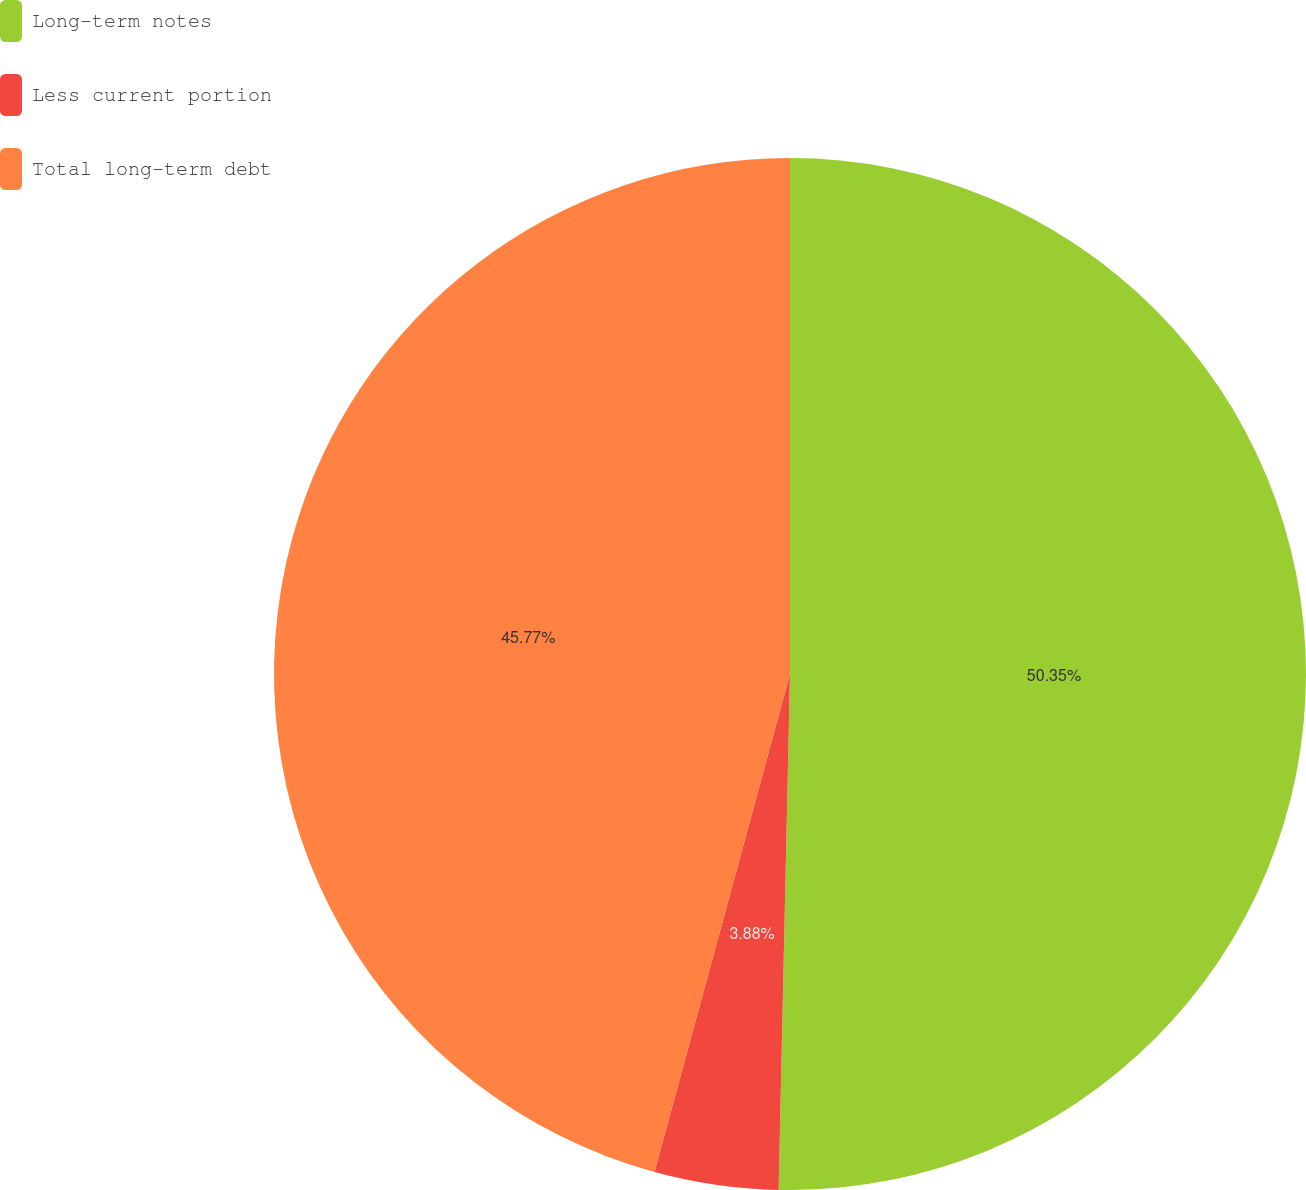Convert chart. <chart><loc_0><loc_0><loc_500><loc_500><pie_chart><fcel>Long-term notes<fcel>Less current portion<fcel>Total long-term debt<nl><fcel>50.35%<fcel>3.88%<fcel>45.77%<nl></chart> 